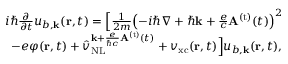<formula> <loc_0><loc_0><loc_500><loc_500>\begin{array} { r } { i \hbar { } \partial } { \partial t } u _ { b , { k } } ( { r } , t ) = \left [ \frac { 1 } { 2 m } { \left ( - i \hbar { \nabla } + \hbar { k } + \frac { e } { c } { A } ^ { ( t ) } ( t ) \right ) } ^ { 2 } } \\ { - e \varphi ( { r } , t ) + \hat { v } _ { N L } ^ { { { k } + \frac { e } { \hbar { c } } { A } ^ { ( t ) } ( t ) } } + { v } _ { x c } ( { r } , t ) \right ] u _ { b , { k } } ( { r } , t ) , } \end{array}</formula> 